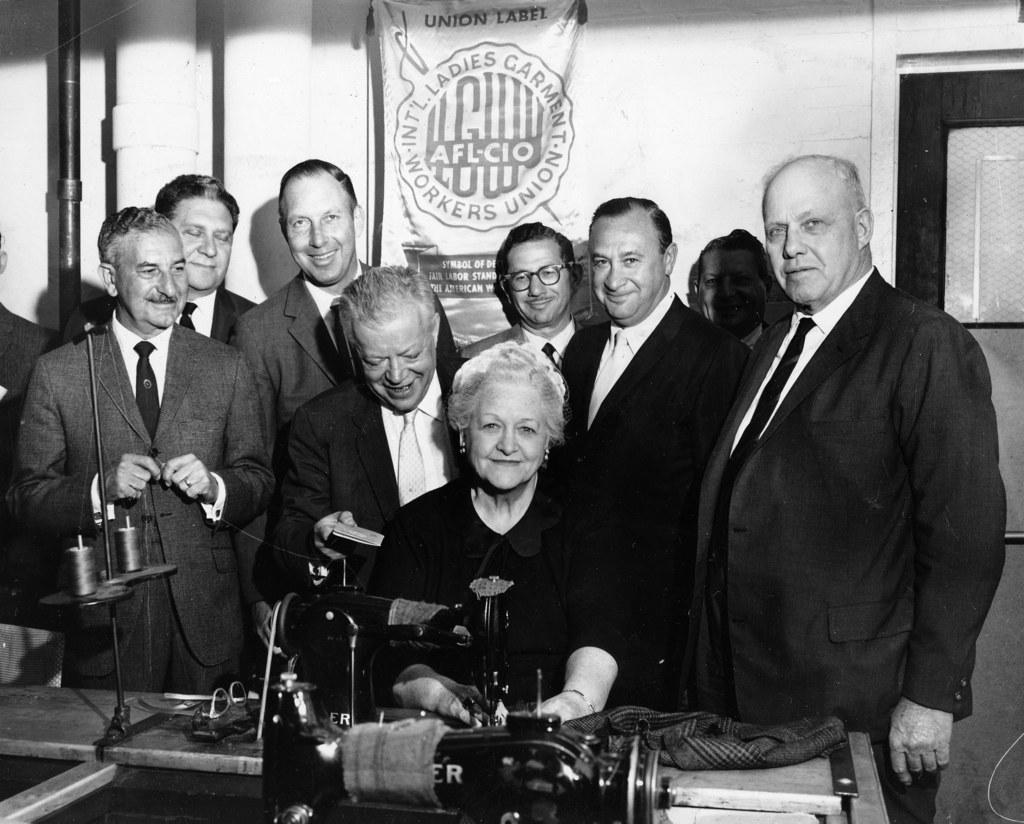Describe this image in one or two sentences. In this picture we can see black and white photo. In the front we can see a group of men wearing a black suit, standing and smiling. In the front we can see a woman wearing black dress, sitting on the chair and smiling. In the front bottom side we can see the sewing machine. Behind we can see white banner and pipe on the wall. 